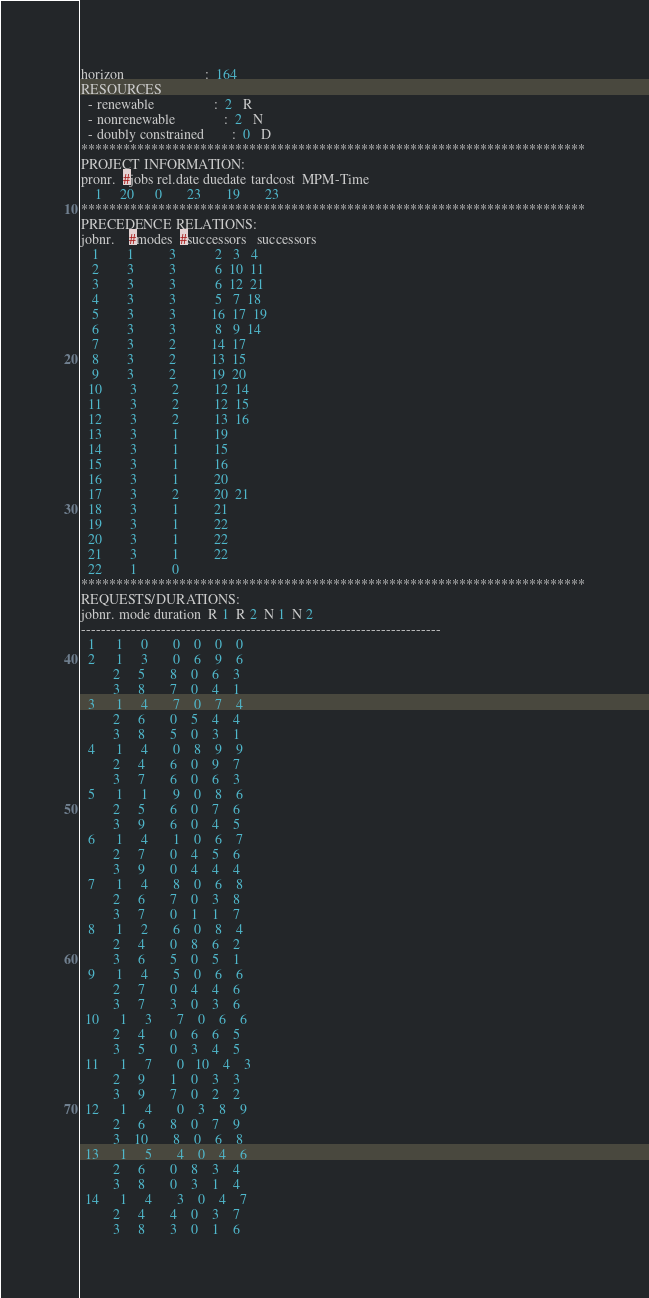Convert code to text. <code><loc_0><loc_0><loc_500><loc_500><_ObjectiveC_>horizon                       :  164
RESOURCES
  - renewable                 :  2   R
  - nonrenewable              :  2   N
  - doubly constrained        :  0   D
************************************************************************
PROJECT INFORMATION:
pronr.  #jobs rel.date duedate tardcost  MPM-Time
    1     20      0       23       19       23
************************************************************************
PRECEDENCE RELATIONS:
jobnr.    #modes  #successors   successors
   1        1          3           2   3   4
   2        3          3           6  10  11
   3        3          3           6  12  21
   4        3          3           5   7  18
   5        3          3          16  17  19
   6        3          3           8   9  14
   7        3          2          14  17
   8        3          2          13  15
   9        3          2          19  20
  10        3          2          12  14
  11        3          2          12  15
  12        3          2          13  16
  13        3          1          19
  14        3          1          15
  15        3          1          16
  16        3          1          20
  17        3          2          20  21
  18        3          1          21
  19        3          1          22
  20        3          1          22
  21        3          1          22
  22        1          0        
************************************************************************
REQUESTS/DURATIONS:
jobnr. mode duration  R 1  R 2  N 1  N 2
------------------------------------------------------------------------
  1      1     0       0    0    0    0
  2      1     3       0    6    9    6
         2     5       8    0    6    3
         3     8       7    0    4    1
  3      1     4       7    0    7    4
         2     6       0    5    4    4
         3     8       5    0    3    1
  4      1     4       0    8    9    9
         2     4       6    0    9    7
         3     7       6    0    6    3
  5      1     1       9    0    8    6
         2     5       6    0    7    6
         3     9       6    0    4    5
  6      1     4       1    0    6    7
         2     7       0    4    5    6
         3     9       0    4    4    4
  7      1     4       8    0    6    8
         2     6       7    0    3    8
         3     7       0    1    1    7
  8      1     2       6    0    8    4
         2     4       0    8    6    2
         3     6       5    0    5    1
  9      1     4       5    0    6    6
         2     7       0    4    4    6
         3     7       3    0    3    6
 10      1     3       7    0    6    6
         2     4       0    6    6    5
         3     5       0    3    4    5
 11      1     7       0   10    4    3
         2     9       1    0    3    3
         3     9       7    0    2    2
 12      1     4       0    3    8    9
         2     6       8    0    7    9
         3    10       8    0    6    8
 13      1     5       4    0    4    6
         2     6       0    8    3    4
         3     8       0    3    1    4
 14      1     4       3    0    4    7
         2     4       4    0    3    7
         3     8       3    0    1    6</code> 